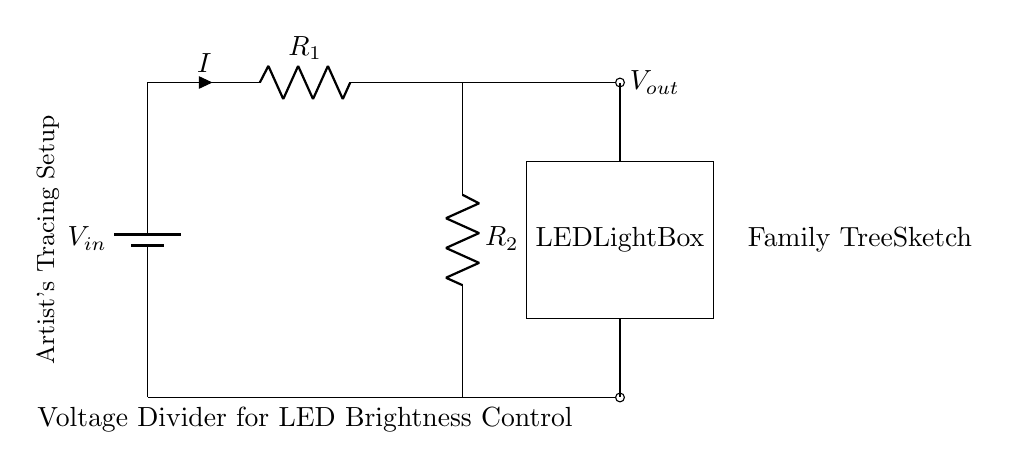What is the type of the circuit depicted? The circuit is a voltage divider, which is specifically designed to divide the input voltage into a lower output voltage based on the resistance values. The configuration shows two resistors in series, creating a voltage division across them.
Answer: Voltage Divider What is the symbol for the LED light box? The LED light box is represented by a rectangle with "LED," "Light," and "Box" inside, indicating that it is a light-emitting diode used for illumination in the circuit.
Answer: LED Light Box What might be the purpose of this circuit? The purpose of this circuit is to adjust the brightness of an LED light box, as indicated by the labeling in the circuit. By changing the voltage output to the LED, one can control how bright the light appears for tracing family tree sketches.
Answer: Adjusting brightness What is the current direction in the circuit? The current flows from the positive terminal of the battery, through the resistors in series (R1 and R2), and then to the LED light box. The indicators show the current direction denoted by the arrow, which is upwards through the resistors.
Answer: Upwards If resistance R1 is doubled while R2 remains constant, how does this affect Vout? Doubling R1 increases the total resistance in series, which causes more voltage to drop across R1 compared to R2. This means Vout decreases since the voltage across R2 (which is Vout) will be a smaller proportion of the total input voltage. Hence, if R1 is doubled, Vout will decrease.
Answer: Decrease What is the relationship between R1 and R2 in this circuit? R1 and R2 are in series, and they proportionally divide the input voltage based on their resistance values. According to the voltage divider formula, the output voltage depends on the respective values of R1 and R2, such that Vout is a fraction of Vin determined by the ratio of R2 to R1 plus R2.
Answer: Proportional division What is the output voltage if R1 is 1k and R2 is 2k, given Vin is 9V? The output voltage is calculated using the voltage divider formula: Vout = Vin * (R2 / (R1 + R2)). Here, Vout = 9V * (2k / (1k + 2k)) = 9V * (2/3) = 6V. So, with these values, the output voltage is 6 volts.
Answer: 6V 